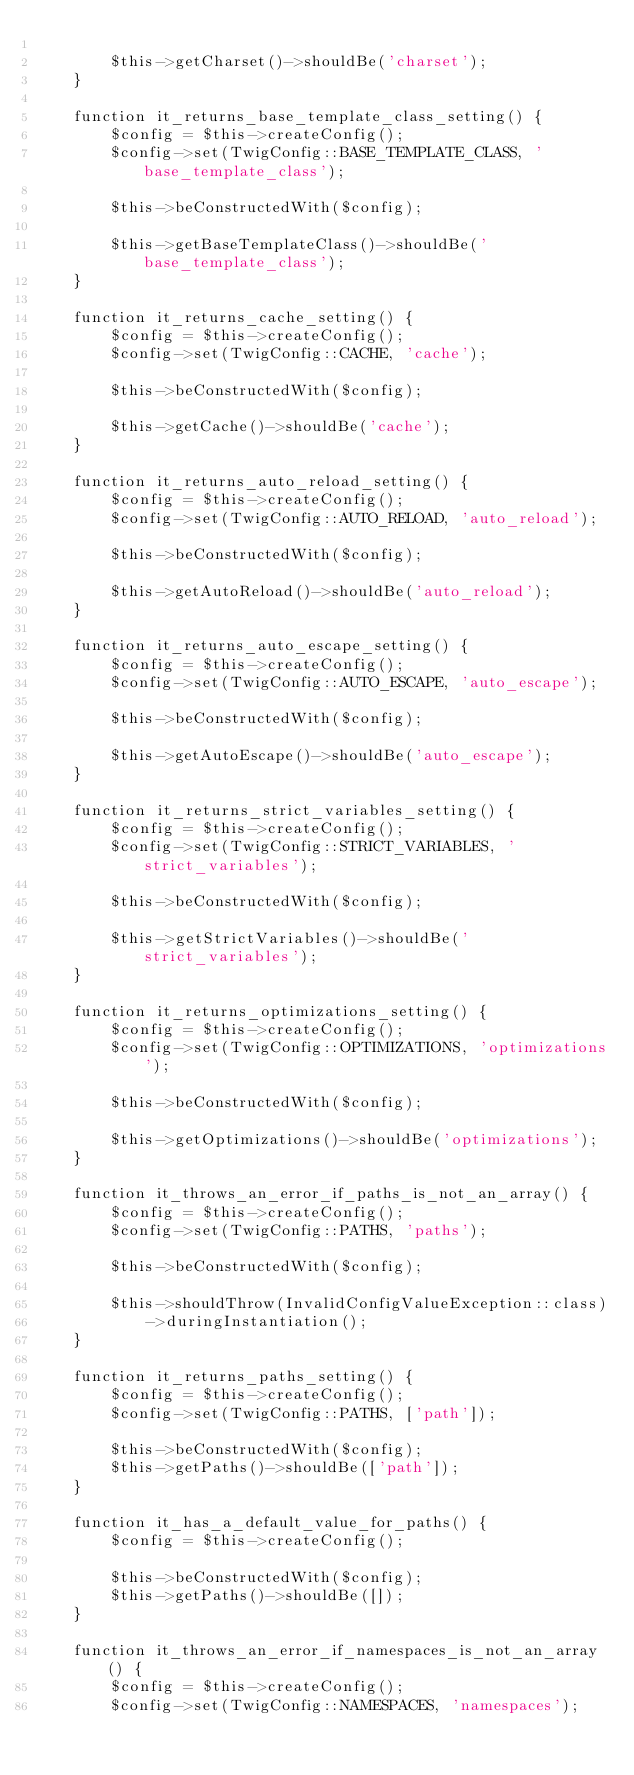<code> <loc_0><loc_0><loc_500><loc_500><_PHP_>
        $this->getCharset()->shouldBe('charset');
    }

    function it_returns_base_template_class_setting() {
        $config = $this->createConfig();
        $config->set(TwigConfig::BASE_TEMPLATE_CLASS, 'base_template_class');

        $this->beConstructedWith($config);

        $this->getBaseTemplateClass()->shouldBe('base_template_class');
    }

    function it_returns_cache_setting() {
        $config = $this->createConfig();
        $config->set(TwigConfig::CACHE, 'cache');

        $this->beConstructedWith($config);

        $this->getCache()->shouldBe('cache');
    }

    function it_returns_auto_reload_setting() {
        $config = $this->createConfig();
        $config->set(TwigConfig::AUTO_RELOAD, 'auto_reload');

        $this->beConstructedWith($config);

        $this->getAutoReload()->shouldBe('auto_reload');
    }

    function it_returns_auto_escape_setting() {
        $config = $this->createConfig();
        $config->set(TwigConfig::AUTO_ESCAPE, 'auto_escape');

        $this->beConstructedWith($config);

        $this->getAutoEscape()->shouldBe('auto_escape');
    }

    function it_returns_strict_variables_setting() {
        $config = $this->createConfig();
        $config->set(TwigConfig::STRICT_VARIABLES, 'strict_variables');

        $this->beConstructedWith($config);

        $this->getStrictVariables()->shouldBe('strict_variables');
    }

    function it_returns_optimizations_setting() {
        $config = $this->createConfig();
        $config->set(TwigConfig::OPTIMIZATIONS, 'optimizations');

        $this->beConstructedWith($config);

        $this->getOptimizations()->shouldBe('optimizations');
    }

    function it_throws_an_error_if_paths_is_not_an_array() {
        $config = $this->createConfig();
        $config->set(TwigConfig::PATHS, 'paths');

        $this->beConstructedWith($config);

        $this->shouldThrow(InvalidConfigValueException::class)
            ->duringInstantiation();
    }

    function it_returns_paths_setting() {
        $config = $this->createConfig();
        $config->set(TwigConfig::PATHS, ['path']);

        $this->beConstructedWith($config);
        $this->getPaths()->shouldBe(['path']);
    }

    function it_has_a_default_value_for_paths() {
        $config = $this->createConfig();

        $this->beConstructedWith($config);
        $this->getPaths()->shouldBe([]);
    }

    function it_throws_an_error_if_namespaces_is_not_an_array() {
        $config = $this->createConfig();
        $config->set(TwigConfig::NAMESPACES, 'namespaces');
</code> 